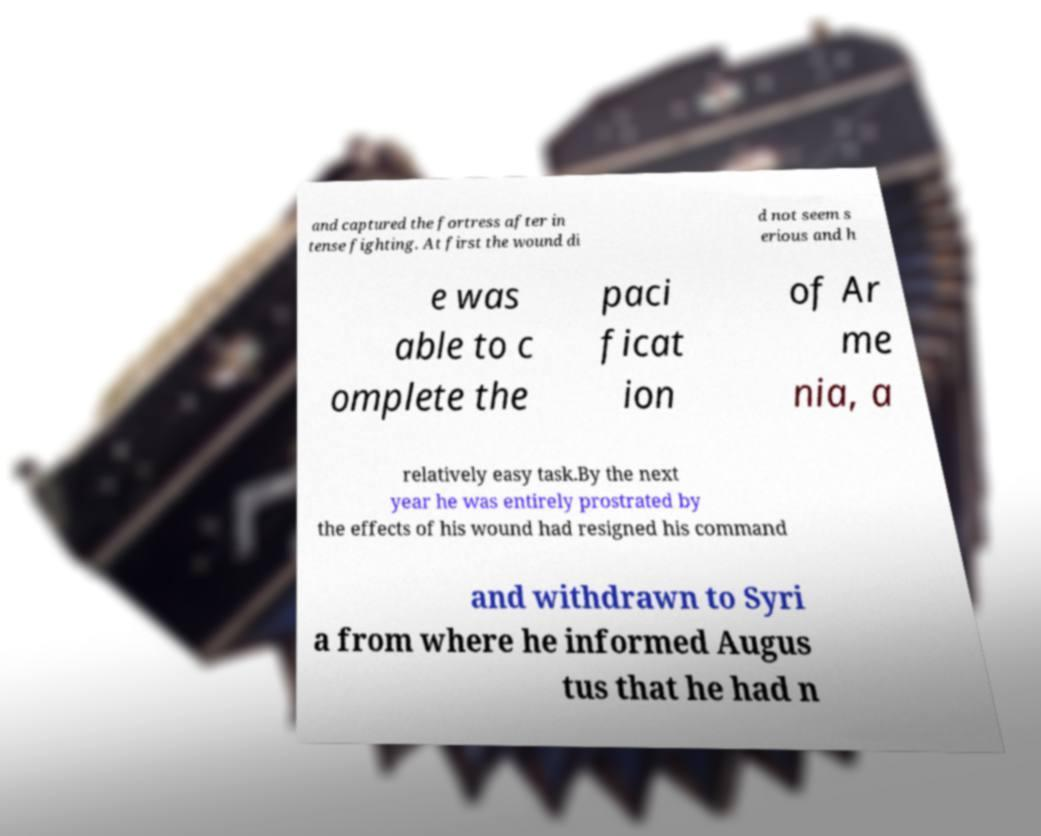Can you accurately transcribe the text from the provided image for me? and captured the fortress after in tense fighting. At first the wound di d not seem s erious and h e was able to c omplete the paci ficat ion of Ar me nia, a relatively easy task.By the next year he was entirely prostrated by the effects of his wound had resigned his command and withdrawn to Syri a from where he informed Augus tus that he had n 